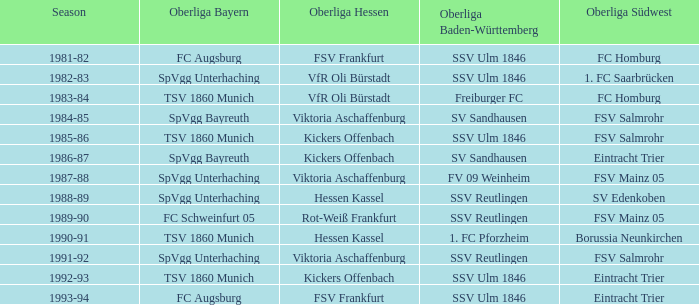In the 1993-94 timeframe, which oberliga baden-württemberg includes an oberliga hessen for fsv frankfurt? SSV Ulm 1846. 